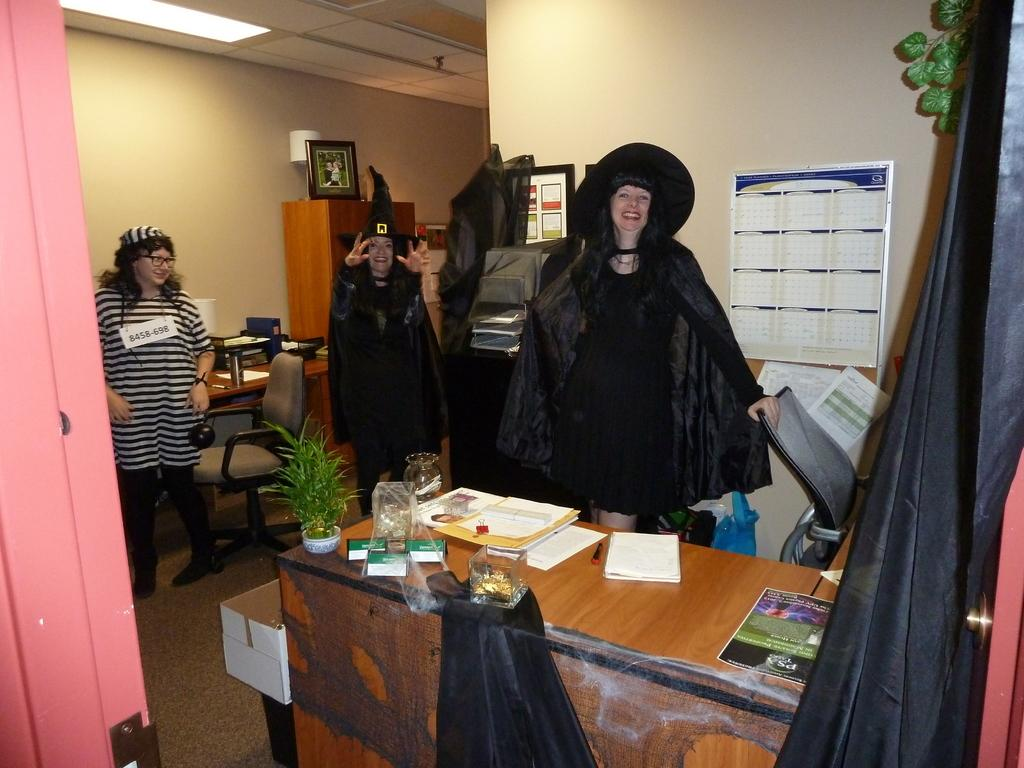How many people are in the image? There is a group of people in the image. What are the people doing in the image? The people are standing on the floor and smiling. What is present in the image besides the people? There is a table in the image. What can be found on the table? There are objects on the table. What type of war is being depicted in the image? There is no war depicted in the image; it features a group of people standing and smiling. Can you tell me how many ears are visible in the image? There is no mention of ears or any body parts in the image; it only features a group of people standing and smiling, as well as a table with objects on it. 